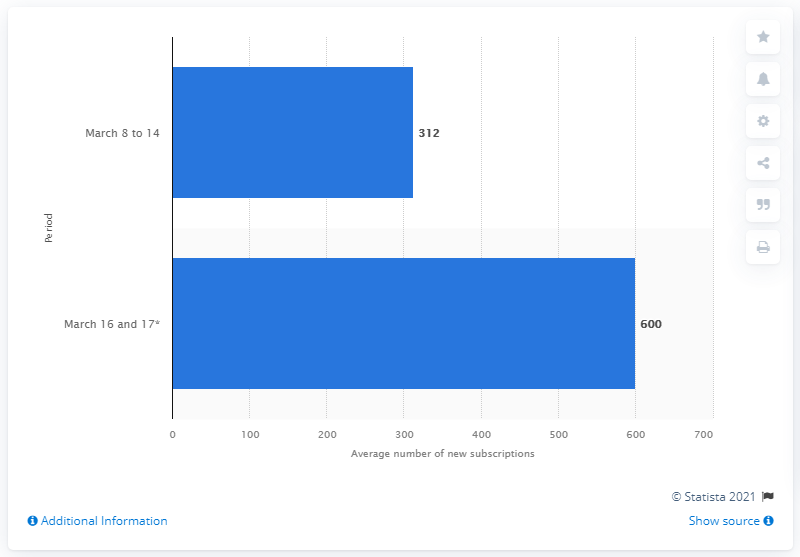Indicate a few pertinent items in this graphic. In March of 2020, Brasileirinhas acquired 600 new subscribers. 